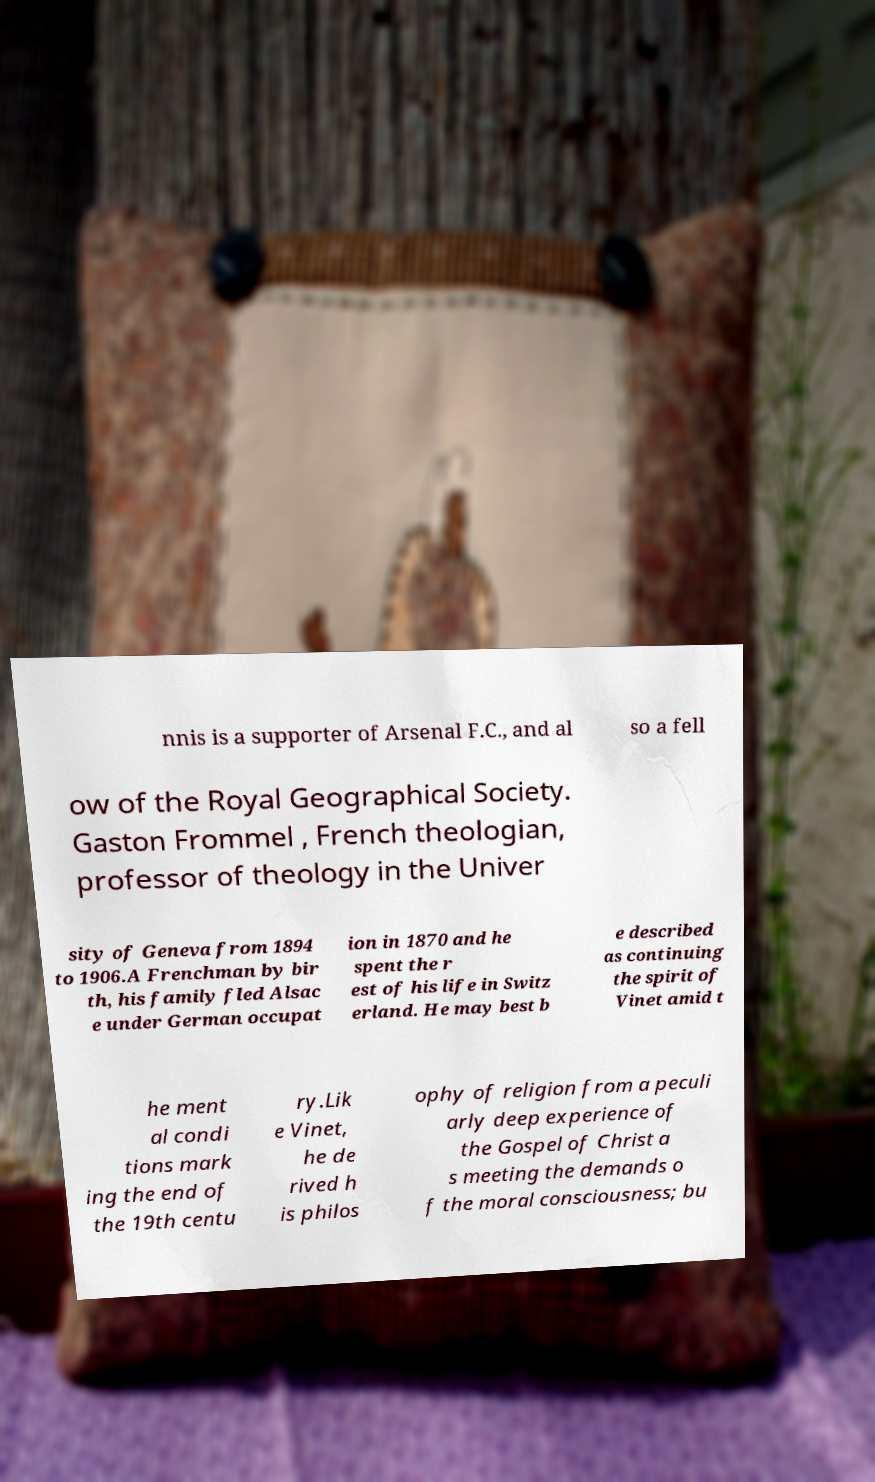Can you accurately transcribe the text from the provided image for me? nnis is a supporter of Arsenal F.C., and al so a fell ow of the Royal Geographical Society. Gaston Frommel , French theologian, professor of theology in the Univer sity of Geneva from 1894 to 1906.A Frenchman by bir th, his family fled Alsac e under German occupat ion in 1870 and he spent the r est of his life in Switz erland. He may best b e described as continuing the spirit of Vinet amid t he ment al condi tions mark ing the end of the 19th centu ry.Lik e Vinet, he de rived h is philos ophy of religion from a peculi arly deep experience of the Gospel of Christ a s meeting the demands o f the moral consciousness; bu 